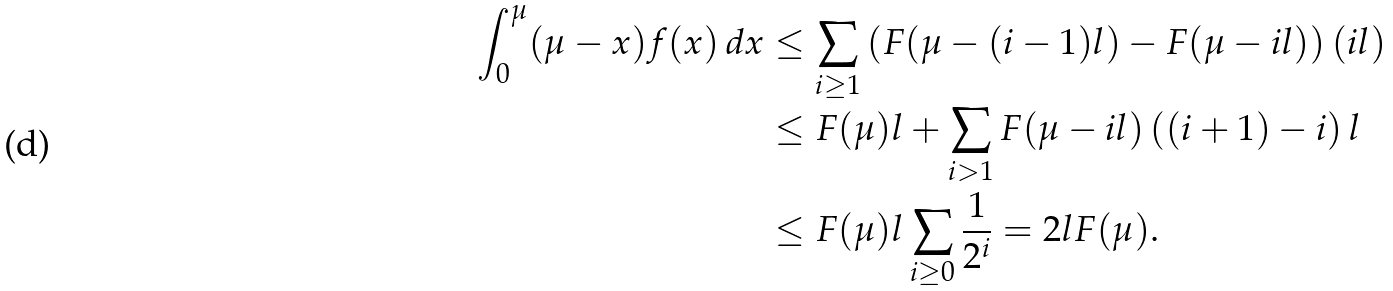Convert formula to latex. <formula><loc_0><loc_0><loc_500><loc_500>\int _ { 0 } ^ { \mu } ( \mu - x ) f ( x ) \, d x & \leq \sum _ { i \geq 1 } \left ( F ( \mu - ( i - 1 ) l ) - F ( \mu - i l ) \right ) ( i l ) \\ & \leq F ( \mu ) l + \sum _ { i > 1 } F ( \mu - i l ) \left ( ( i + 1 ) - i \right ) l \\ & \leq F ( \mu ) l \sum _ { i \geq 0 } \frac { 1 } { 2 ^ { i } } = 2 l F ( \mu ) .</formula> 